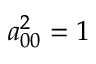<formula> <loc_0><loc_0><loc_500><loc_500>a _ { 0 0 } ^ { 2 } = 1</formula> 